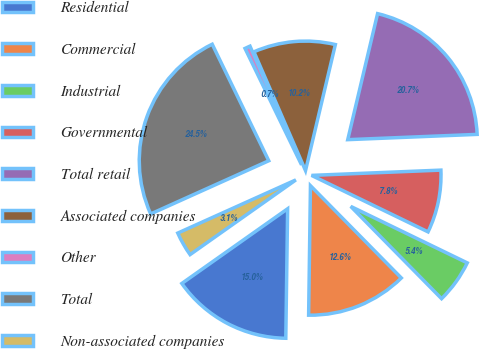Convert chart. <chart><loc_0><loc_0><loc_500><loc_500><pie_chart><fcel>Residential<fcel>Commercial<fcel>Industrial<fcel>Governmental<fcel>Total retail<fcel>Associated companies<fcel>Other<fcel>Total<fcel>Non-associated companies<nl><fcel>14.99%<fcel>12.6%<fcel>5.44%<fcel>7.83%<fcel>20.65%<fcel>10.22%<fcel>0.67%<fcel>24.54%<fcel>3.05%<nl></chart> 